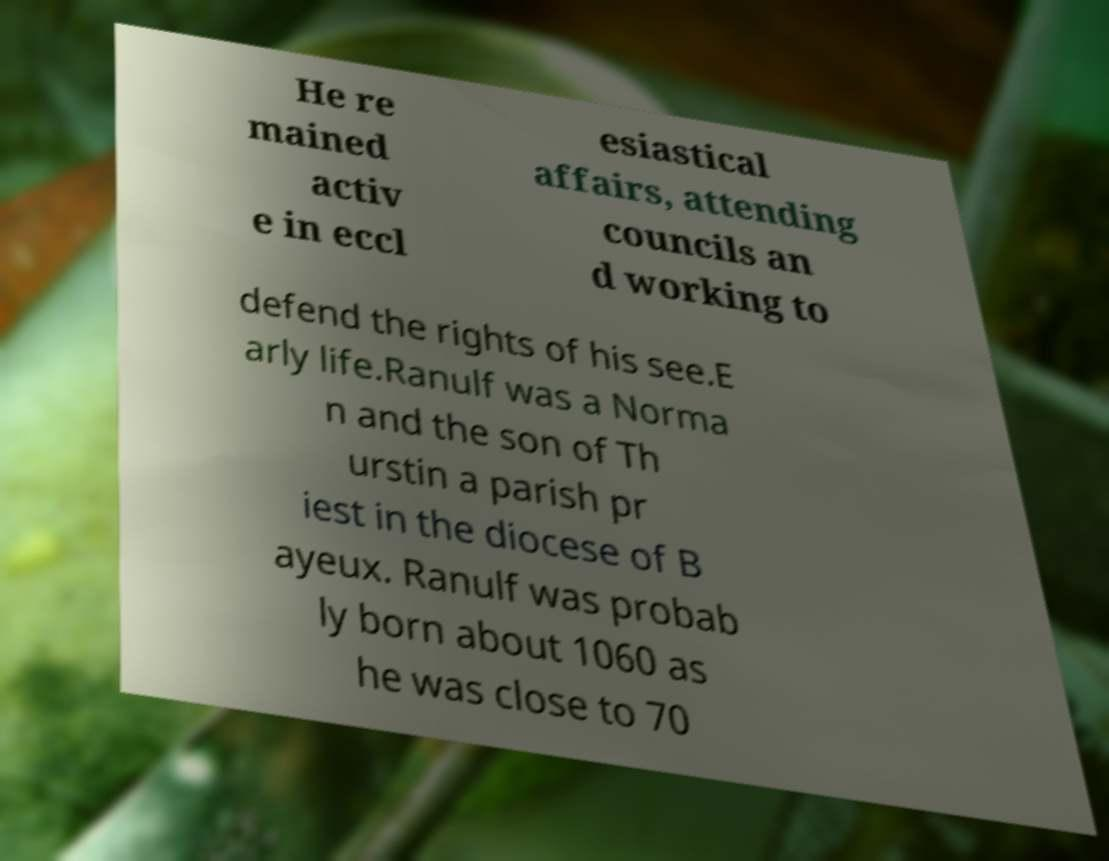Please identify and transcribe the text found in this image. He re mained activ e in eccl esiastical affairs, attending councils an d working to defend the rights of his see.E arly life.Ranulf was a Norma n and the son of Th urstin a parish pr iest in the diocese of B ayeux. Ranulf was probab ly born about 1060 as he was close to 70 